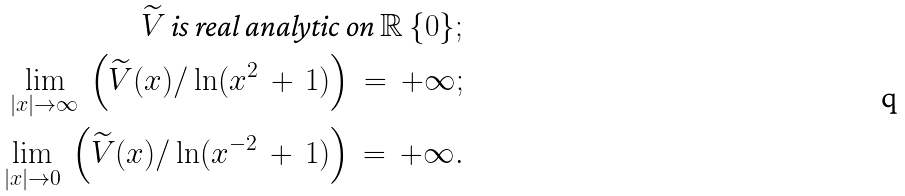Convert formula to latex. <formula><loc_0><loc_0><loc_500><loc_500>\widetilde { V } \, \text {is real analytic on} \, \mathbb { R } \ \{ 0 \} ; \\ \lim _ { | x | \to \infty } \, \left ( \widetilde { V } ( x ) / \ln ( x ^ { 2 } \, + \, 1 ) \right ) \, = \, + \infty ; \\ \lim _ { | x | \to 0 } \, \left ( \widetilde { V } ( x ) / \ln ( x ^ { - 2 } \, + \, 1 ) \right ) \, = \, + \infty .</formula> 